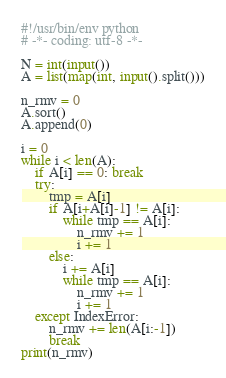<code> <loc_0><loc_0><loc_500><loc_500><_Python_>#!/usr/bin/env python
# -*- coding: utf-8 -*-

N = int(input())
A = list(map(int, input().split()))

n_rmv = 0
A.sort()
A.append(0)

i = 0
while i < len(A):
    if A[i] == 0: break
    try:
        tmp = A[i]
        if A[i+A[i]-1] != A[i]:
            while tmp == A[i]:
                n_rmv += 1
                i += 1
        else:
            i += A[i]
            while tmp == A[i]:
                n_rmv += 1
                i += 1
    except IndexError:
        n_rmv += len(A[i:-1])
        break
print(n_rmv)
</code> 